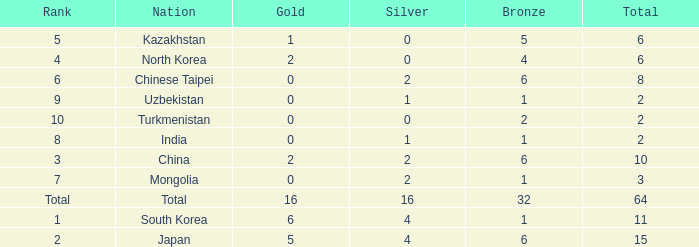What is the total Gold's less than 0? 0.0. 